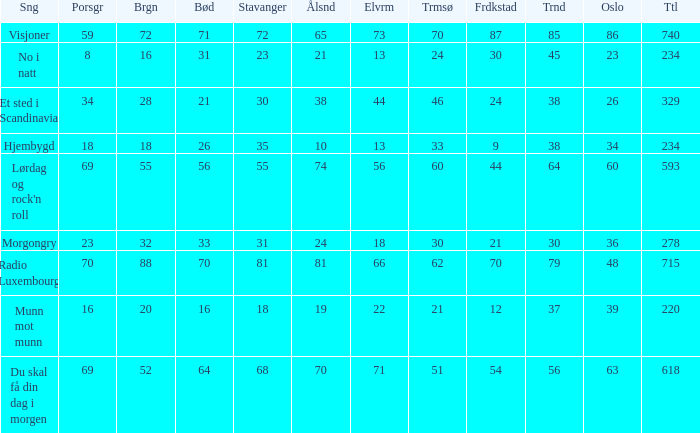When bergen is 88, what is the alesund? 81.0. 